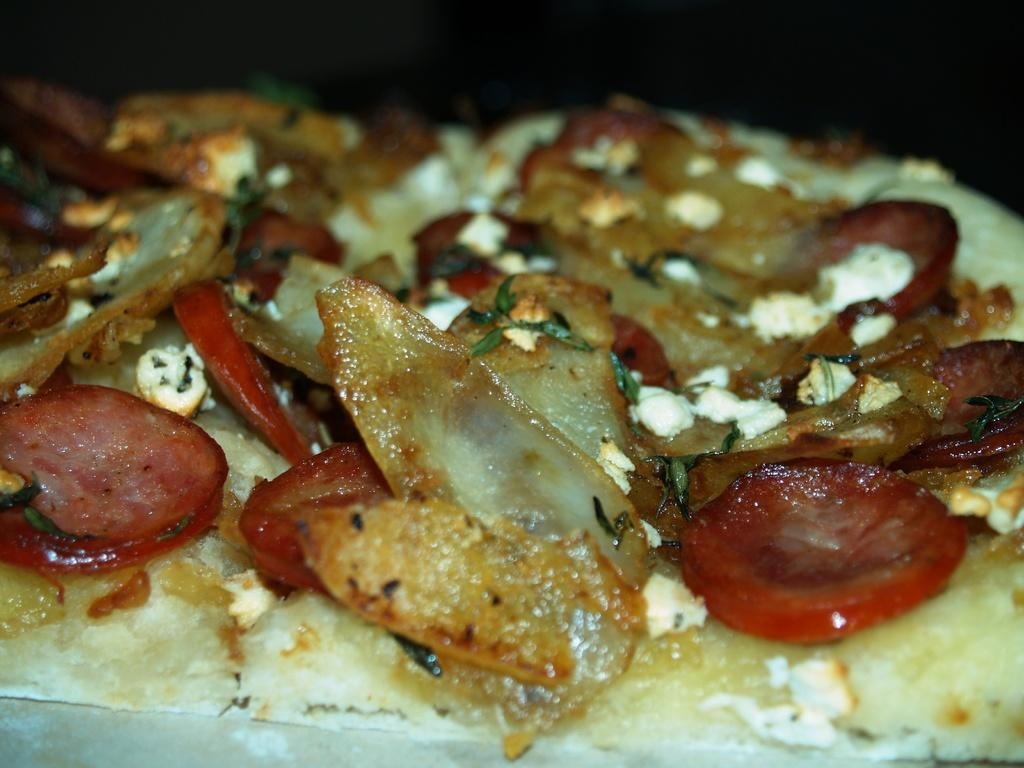What can be seen in the image? There is a food item in the image. Can you describe the lighting in the image? The top of the image is dark. How many feet are visible in the image? There are no feet visible in the image; it only contains a food item. What type of hair can be seen on the loaf in the image? There is no loaf or hair present in the image. 